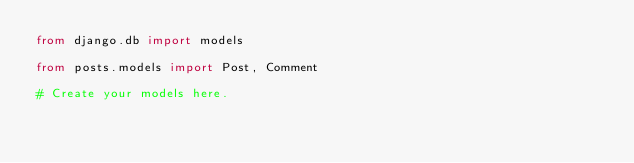Convert code to text. <code><loc_0><loc_0><loc_500><loc_500><_Python_>from django.db import models

from posts.models import Post, Comment

# Create your models here.
</code> 